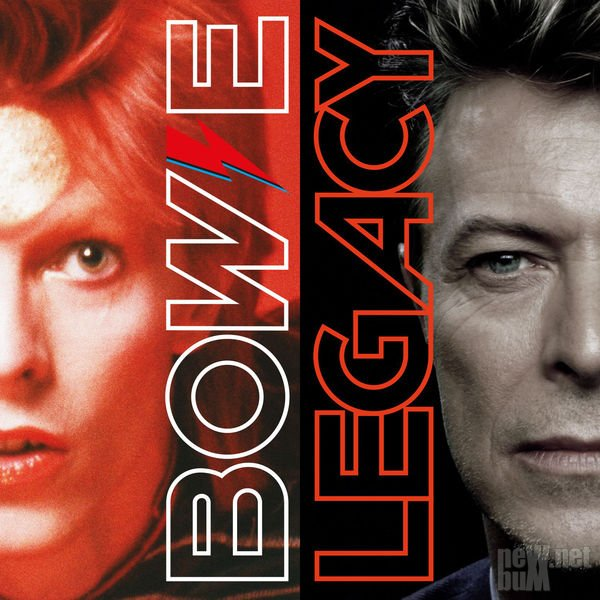Describe the possible symbolism behind the contrasting images in the portrait. The contrasting images in the portrait likely symbolize the evolution and multifaceted nature of the individual's career. The left side, with its bold lightning bolt and vibrant hair, symbolizes a phase of energy, transformation, and rebellion, possibly marking the beginning of their journey marked by experimentation. The right side, with a more subdued and mature appearance, could represent a later stage reflecting wisdom, experience, and legacy. This contrast highlights the dynamic range and enduring impact of the individual's work over time. Could these images represent different personas or characters? Yes, the contrasting images could indeed represent different personas or characters adopted by the individual. Many artists create distinct alter egos to explore various musical and artistic themes, allowing them to push creative boundaries and connect with diverse audiences. These personas often come with unique aesthetics and performance styles, contributing to a rich and varied career that evolves with time. 